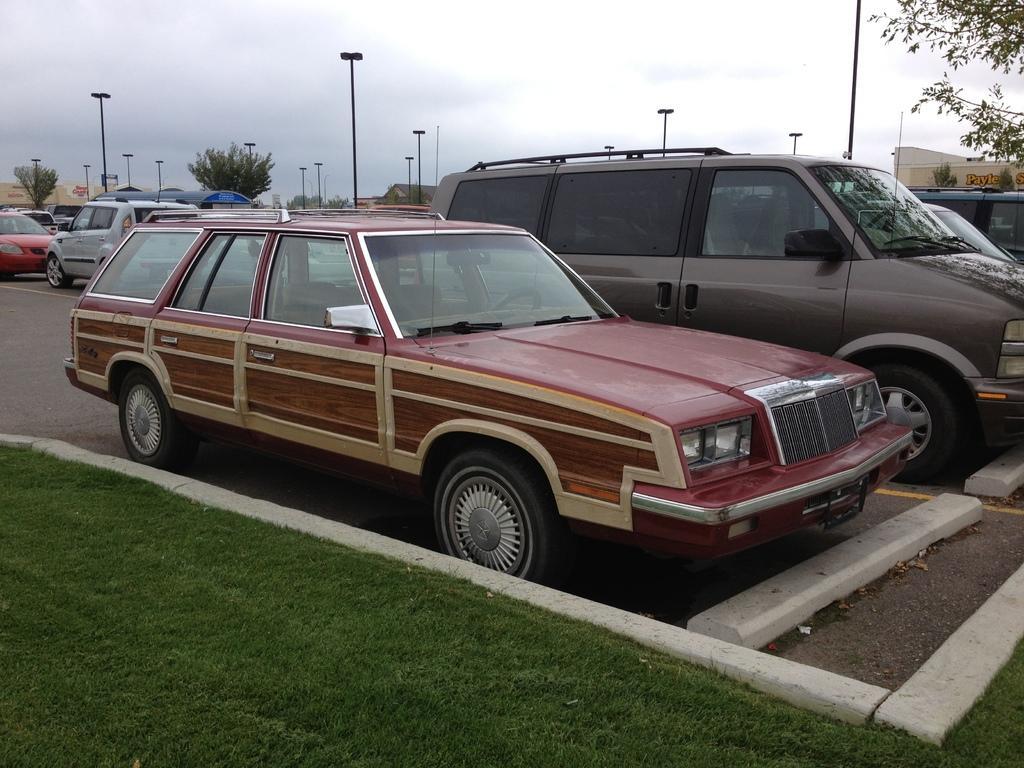Can you describe this image briefly? In this image there are cars parked on the road one beside the other. In between the cars there are poles. At the bottom there is grass. On the right side top there is a building. 